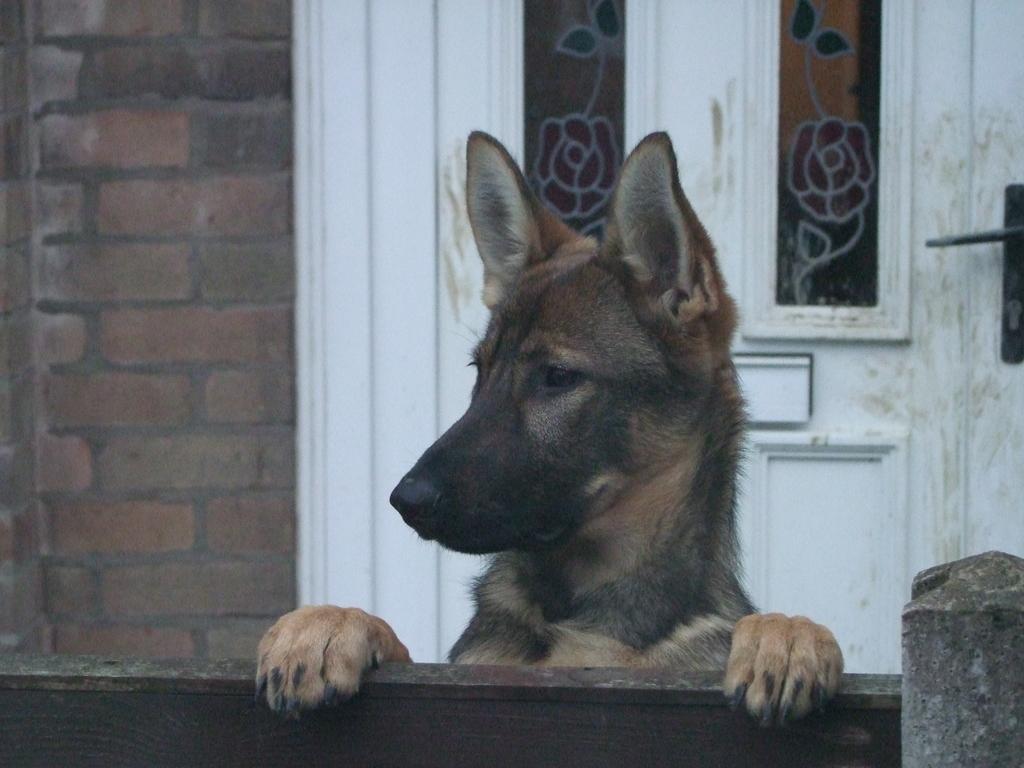How would you summarize this image in a sentence or two? In this picture we can observe a dog which is in black and brown color. This is a German shepherd. In the background there is a wall and a white color door. 